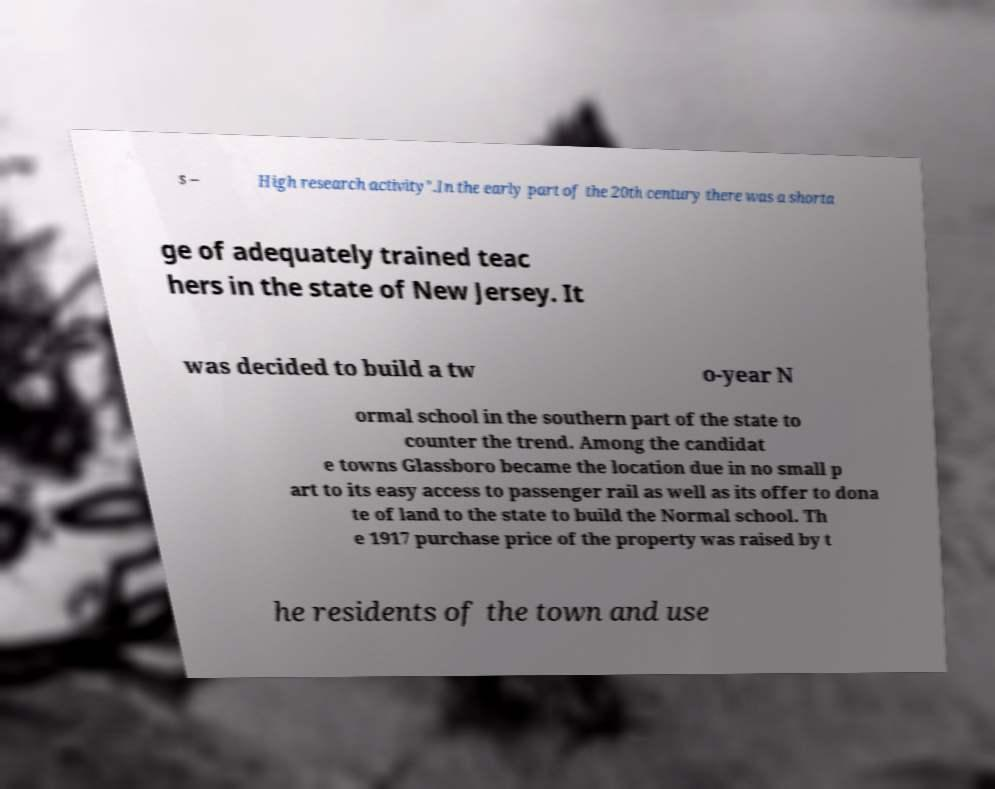What messages or text are displayed in this image? I need them in a readable, typed format. s – High research activity".In the early part of the 20th century there was a shorta ge of adequately trained teac hers in the state of New Jersey. It was decided to build a tw o-year N ormal school in the southern part of the state to counter the trend. Among the candidat e towns Glassboro became the location due in no small p art to its easy access to passenger rail as well as its offer to dona te of land to the state to build the Normal school. Th e 1917 purchase price of the property was raised by t he residents of the town and use 